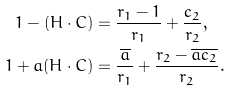<formula> <loc_0><loc_0><loc_500><loc_500>1 - ( H \cdot C ) & = \frac { r _ { 1 } - 1 } { r _ { 1 } } + \frac { c _ { 2 } } { r _ { 2 } } , \\ 1 + a ( H \cdot C ) & = \frac { \overline { a } } { r _ { 1 } } + \frac { r _ { 2 } - \overline { a c _ { 2 } } } { r _ { 2 } } .</formula> 